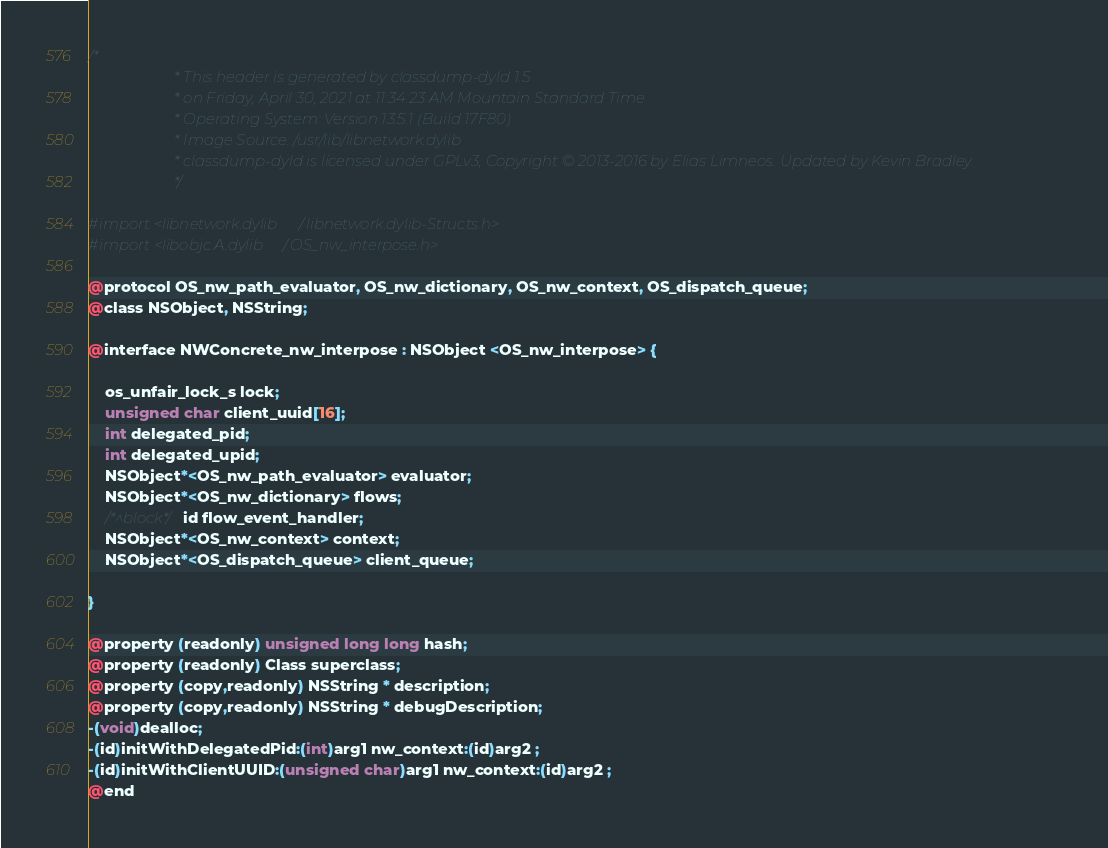Convert code to text. <code><loc_0><loc_0><loc_500><loc_500><_C_>/*
                       * This header is generated by classdump-dyld 1.5
                       * on Friday, April 30, 2021 at 11:34:23 AM Mountain Standard Time
                       * Operating System: Version 13.5.1 (Build 17F80)
                       * Image Source: /usr/lib/libnetwork.dylib
                       * classdump-dyld is licensed under GPLv3, Copyright © 2013-2016 by Elias Limneos. Updated by Kevin Bradley.
                       */

#import <libnetwork.dylib/libnetwork.dylib-Structs.h>
#import <libobjc.A.dylib/OS_nw_interpose.h>

@protocol OS_nw_path_evaluator, OS_nw_dictionary, OS_nw_context, OS_dispatch_queue;
@class NSObject, NSString;

@interface NWConcrete_nw_interpose : NSObject <OS_nw_interpose> {

	os_unfair_lock_s lock;
	unsigned char client_uuid[16];
	int delegated_pid;
	int delegated_upid;
	NSObject*<OS_nw_path_evaluator> evaluator;
	NSObject*<OS_nw_dictionary> flows;
	/*^block*/id flow_event_handler;
	NSObject*<OS_nw_context> context;
	NSObject*<OS_dispatch_queue> client_queue;

}

@property (readonly) unsigned long long hash; 
@property (readonly) Class superclass; 
@property (copy,readonly) NSString * description; 
@property (copy,readonly) NSString * debugDescription; 
-(void)dealloc;
-(id)initWithDelegatedPid:(int)arg1 nw_context:(id)arg2 ;
-(id)initWithClientUUID:(unsigned char)arg1 nw_context:(id)arg2 ;
@end

</code> 